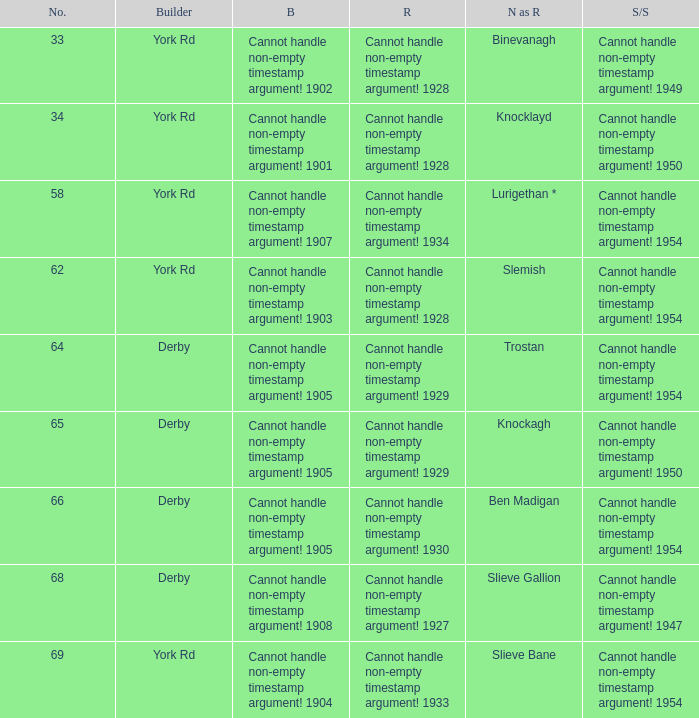Which Scrapped/Sold has a Builder of derby, and a Name as rebuilt of ben madigan? Cannot handle non-empty timestamp argument! 1954. 